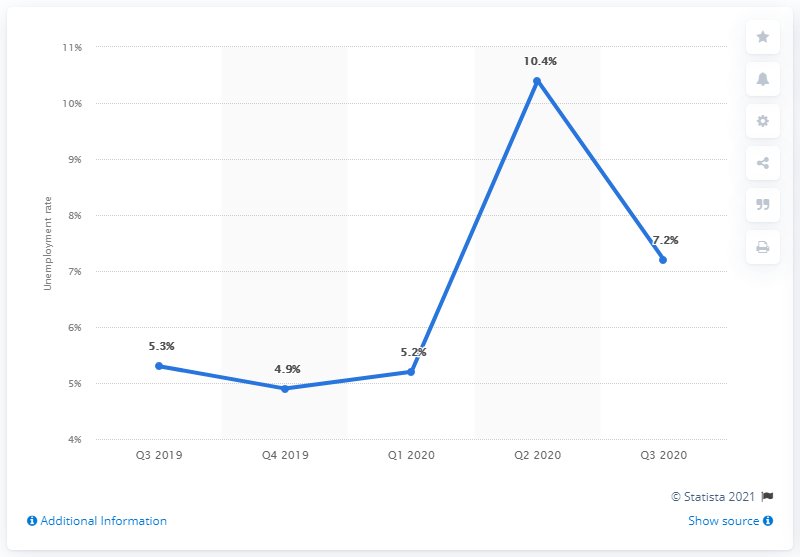Specify some key components in this picture. The unemployment rate in Kenya during the previous quarter was 10.4%. In the third quarter of 2019, the unemployment rate was 5.3%. In the third quarter of 2020, the unemployment rate in Kenya was 7.2%. 